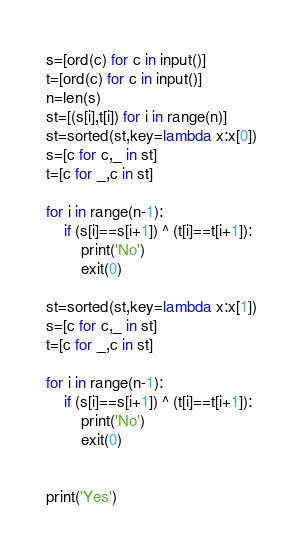<code> <loc_0><loc_0><loc_500><loc_500><_Python_>s=[ord(c) for c in input()]
t=[ord(c) for c in input()]
n=len(s)
st=[(s[i],t[i]) for i in range(n)]
st=sorted(st,key=lambda x:x[0])
s=[c for c,_ in st]
t=[c for _,c in st]

for i in range(n-1):
    if (s[i]==s[i+1]) ^ (t[i]==t[i+1]):
        print('No')
        exit(0)

st=sorted(st,key=lambda x:x[1])
s=[c for c,_ in st]
t=[c for _,c in st]

for i in range(n-1):
    if (s[i]==s[i+1]) ^ (t[i]==t[i+1]):
        print('No')
        exit(0)


print('Yes')</code> 